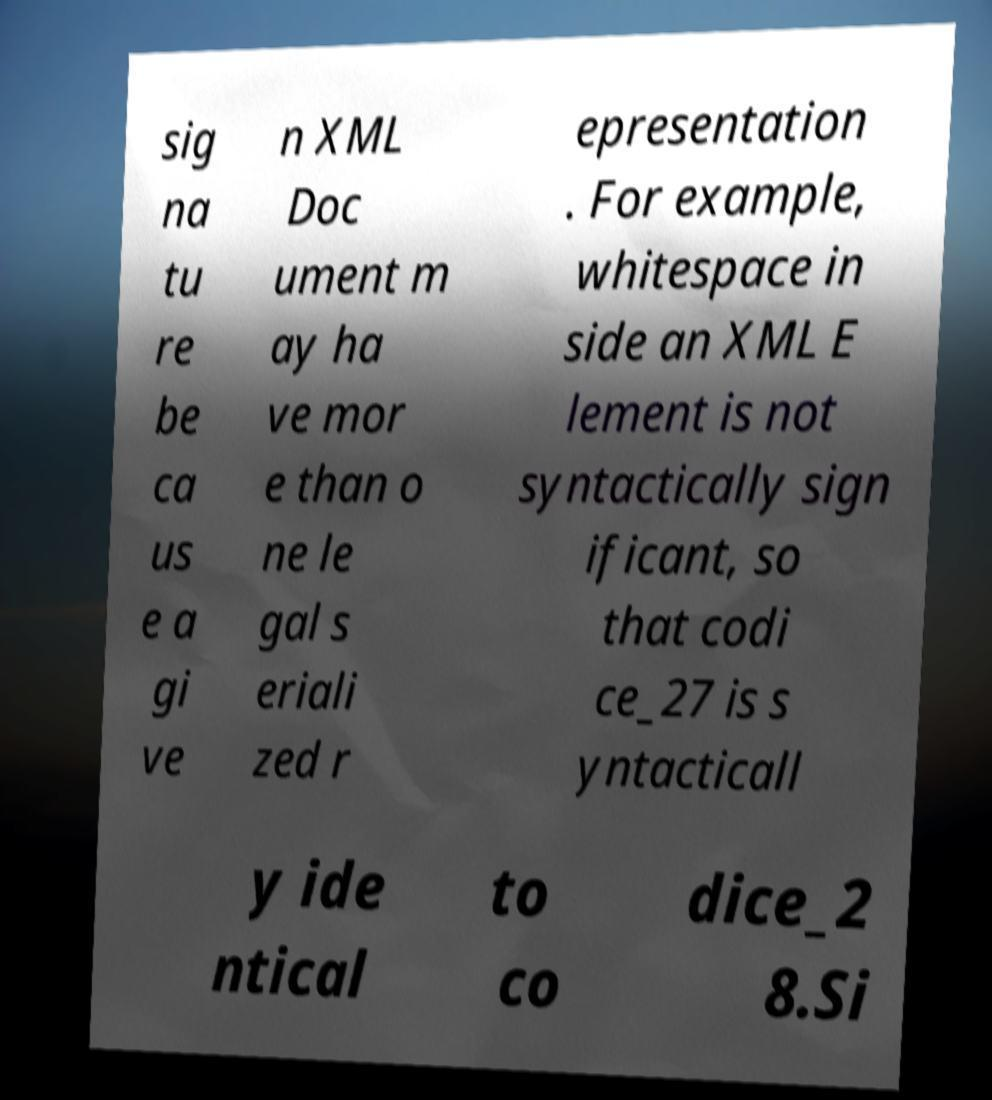Can you read and provide the text displayed in the image?This photo seems to have some interesting text. Can you extract and type it out for me? sig na tu re be ca us e a gi ve n XML Doc ument m ay ha ve mor e than o ne le gal s eriali zed r epresentation . For example, whitespace in side an XML E lement is not syntactically sign ificant, so that codi ce_27 is s yntacticall y ide ntical to co dice_2 8.Si 